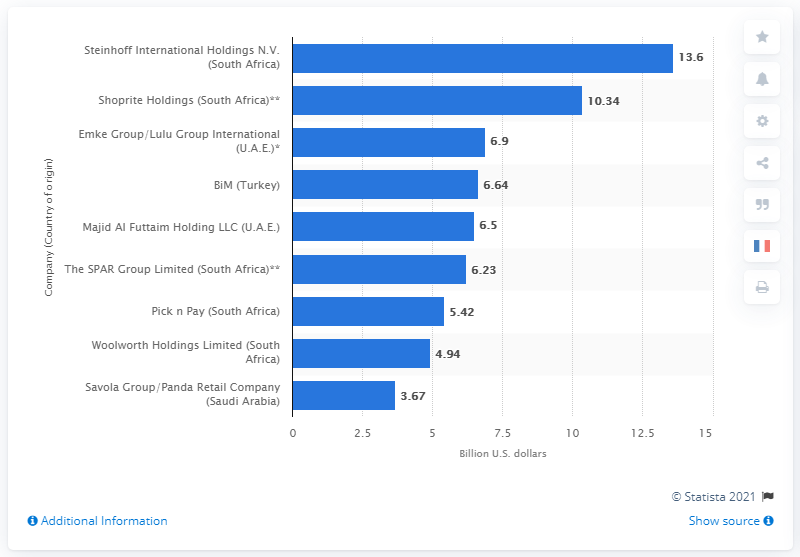Draw attention to some important aspects in this diagram. In 2016, Steinhoff International Holdings N.V. generated approximately 13.6 billion US dollars in sales in the United States. 